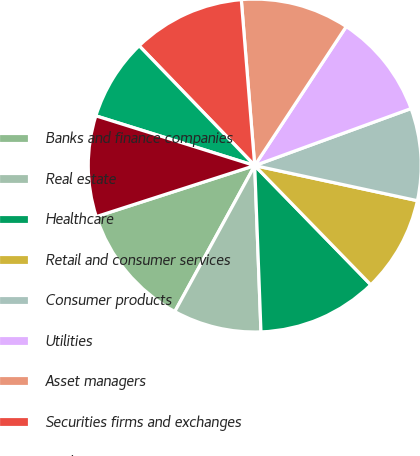Convert chart to OTSL. <chart><loc_0><loc_0><loc_500><loc_500><pie_chart><fcel>Banks and finance companies<fcel>Real estate<fcel>Healthcare<fcel>Retail and consumer services<fcel>Consumer products<fcel>Utilities<fcel>Asset managers<fcel>Securities firms and exchanges<fcel>Media<fcel>All other<nl><fcel>12.07%<fcel>8.57%<fcel>11.69%<fcel>9.33%<fcel>8.95%<fcel>10.17%<fcel>10.55%<fcel>10.93%<fcel>7.96%<fcel>9.79%<nl></chart> 